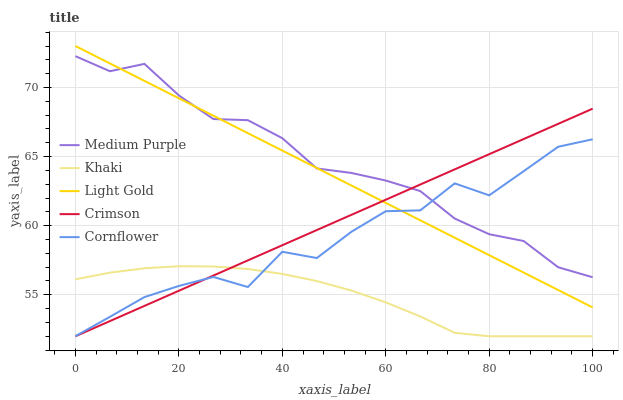Does Khaki have the minimum area under the curve?
Answer yes or no. Yes. Does Crimson have the minimum area under the curve?
Answer yes or no. No. Does Crimson have the maximum area under the curve?
Answer yes or no. No. Is Cornflower the roughest?
Answer yes or no. Yes. Is Khaki the smoothest?
Answer yes or no. No. Is Khaki the roughest?
Answer yes or no. No. Does Light Gold have the lowest value?
Answer yes or no. No. Does Crimson have the highest value?
Answer yes or no. No. Is Khaki less than Light Gold?
Answer yes or no. Yes. Is Light Gold greater than Khaki?
Answer yes or no. Yes. Does Khaki intersect Light Gold?
Answer yes or no. No. 